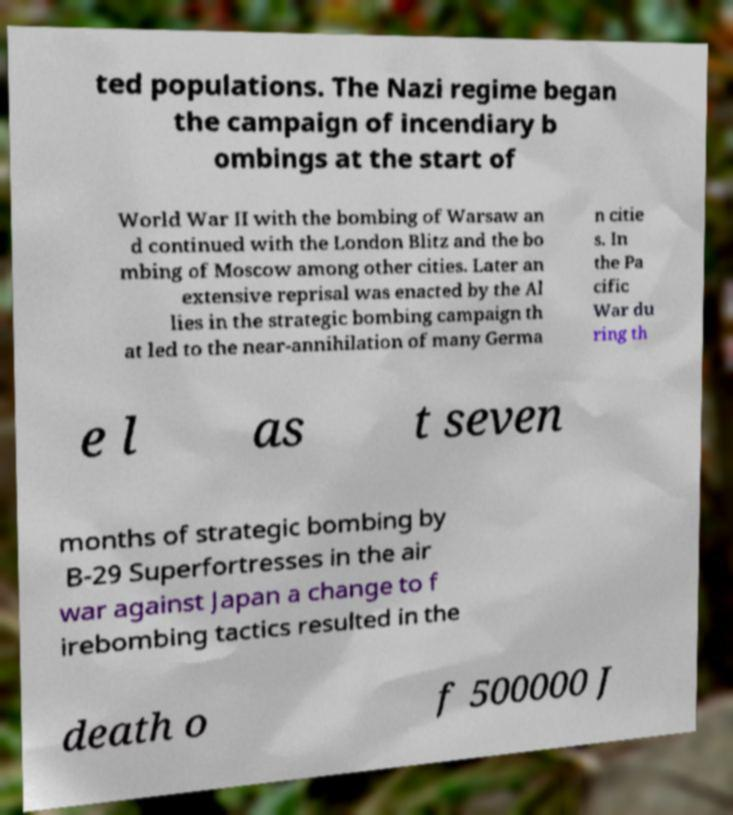Please read and relay the text visible in this image. What does it say? ted populations. The Nazi regime began the campaign of incendiary b ombings at the start of World War II with the bombing of Warsaw an d continued with the London Blitz and the bo mbing of Moscow among other cities. Later an extensive reprisal was enacted by the Al lies in the strategic bombing campaign th at led to the near-annihilation of many Germa n citie s. In the Pa cific War du ring th e l as t seven months of strategic bombing by B-29 Superfortresses in the air war against Japan a change to f irebombing tactics resulted in the death o f 500000 J 